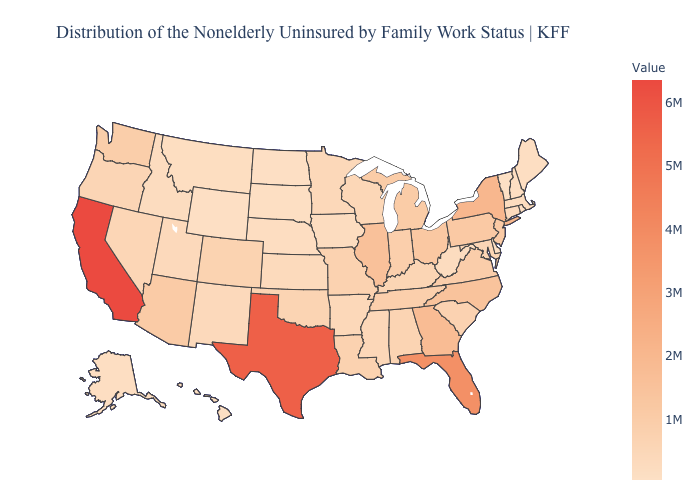Does Florida have a higher value than California?
Give a very brief answer. No. Among the states that border Louisiana , which have the highest value?
Write a very short answer. Texas. Does Florida have the highest value in the USA?
Concise answer only. No. Among the states that border Ohio , which have the highest value?
Keep it brief. Pennsylvania. Among the states that border Montana , which have the highest value?
Answer briefly. Idaho. Which states have the lowest value in the MidWest?
Keep it brief. North Dakota. Does Vermont have the lowest value in the USA?
Give a very brief answer. Yes. Does Alabama have a lower value than Illinois?
Short answer required. Yes. Which states hav the highest value in the MidWest?
Give a very brief answer. Illinois. 